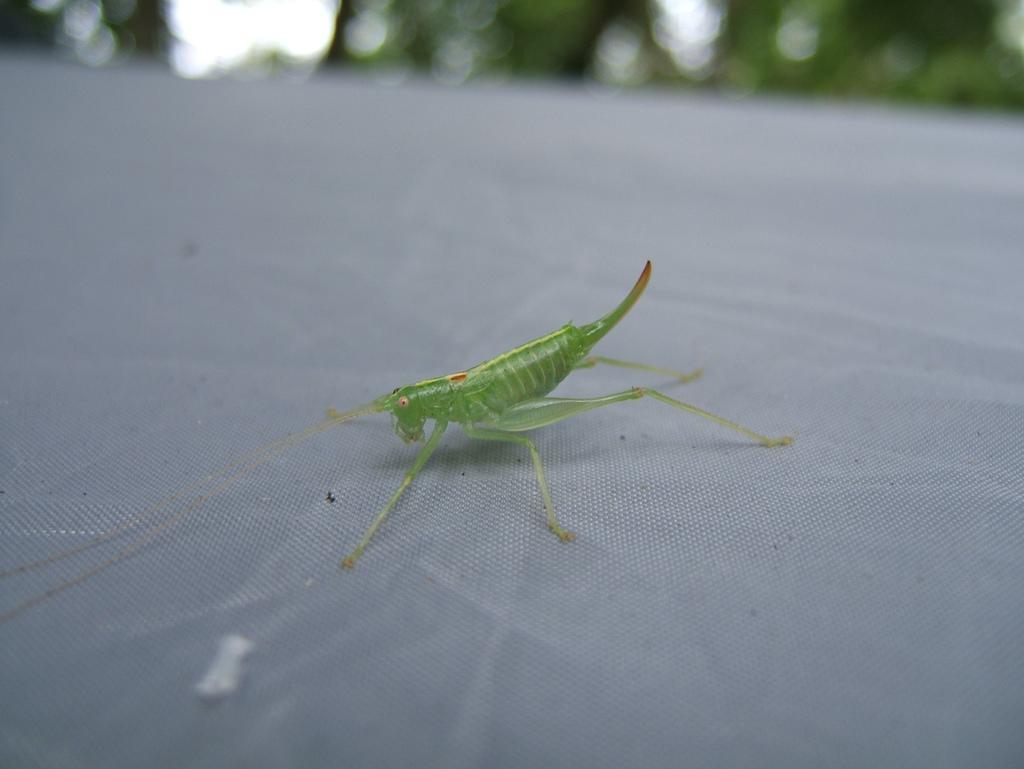In one or two sentences, can you explain what this image depicts? In this image, I can see a grasshopper on an object. There is a blurred background. 